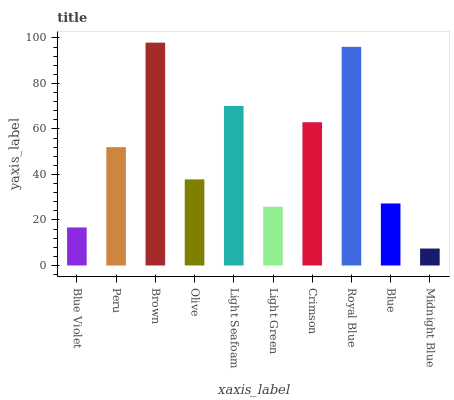Is Midnight Blue the minimum?
Answer yes or no. Yes. Is Brown the maximum?
Answer yes or no. Yes. Is Peru the minimum?
Answer yes or no. No. Is Peru the maximum?
Answer yes or no. No. Is Peru greater than Blue Violet?
Answer yes or no. Yes. Is Blue Violet less than Peru?
Answer yes or no. Yes. Is Blue Violet greater than Peru?
Answer yes or no. No. Is Peru less than Blue Violet?
Answer yes or no. No. Is Peru the high median?
Answer yes or no. Yes. Is Olive the low median?
Answer yes or no. Yes. Is Blue Violet the high median?
Answer yes or no. No. Is Midnight Blue the low median?
Answer yes or no. No. 